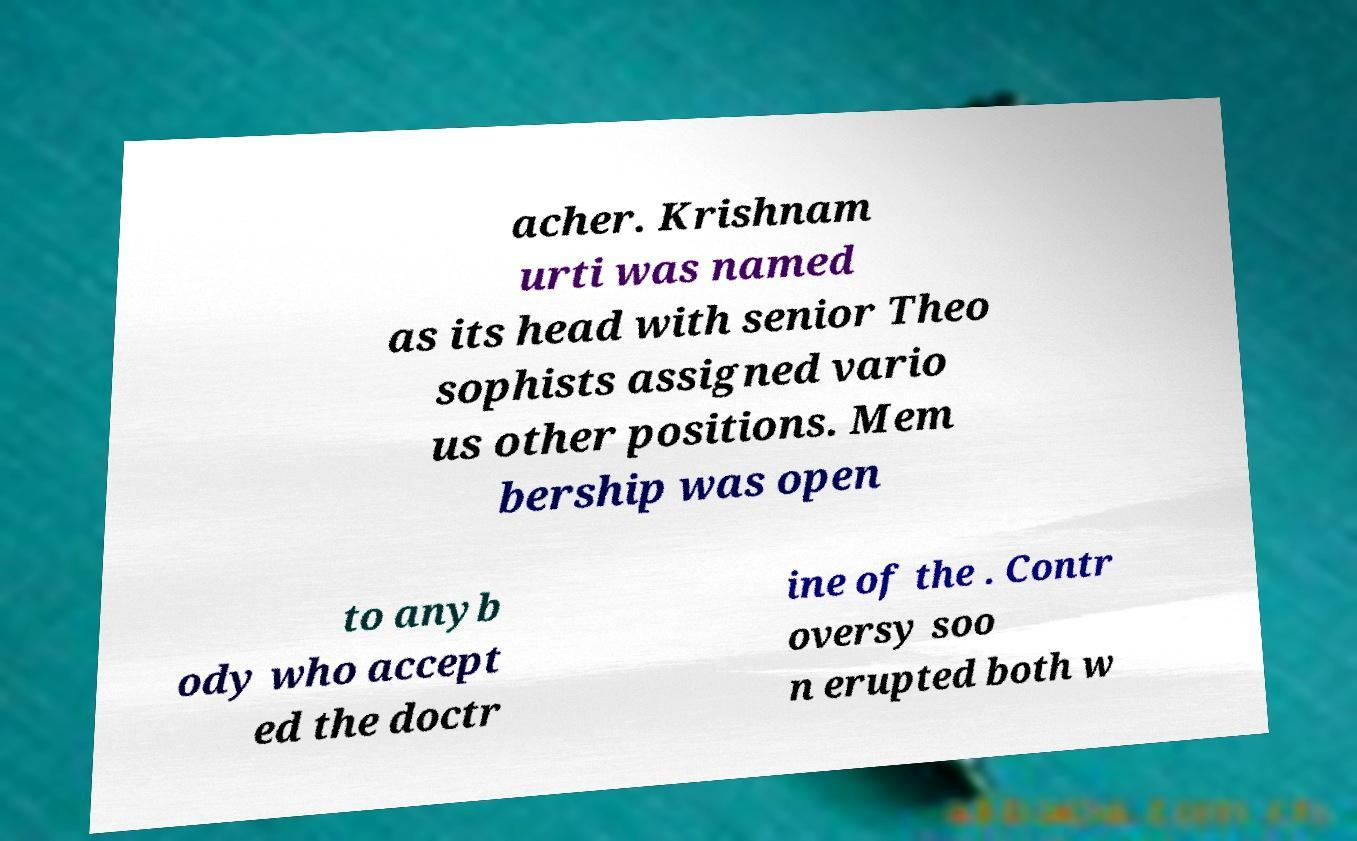Can you read and provide the text displayed in the image?This photo seems to have some interesting text. Can you extract and type it out for me? acher. Krishnam urti was named as its head with senior Theo sophists assigned vario us other positions. Mem bership was open to anyb ody who accept ed the doctr ine of the . Contr oversy soo n erupted both w 